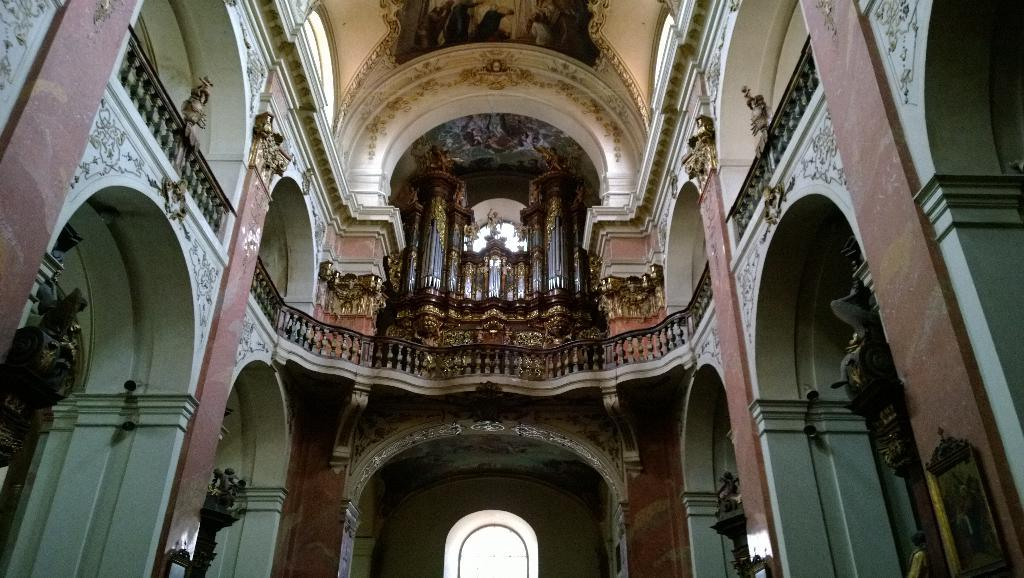What type of location is depicted in the image? The image shows an inside view of a building. What can be seen on the left side of the image? There is a sculpture on the left side of the image. What can be seen on the right side of the image? There is another sculpture on the right side of the image. What type of chalk is being used to draw on the sculpture on the left side of the image? There is no chalk or drawing activity present in the image; it only shows two sculptures. 